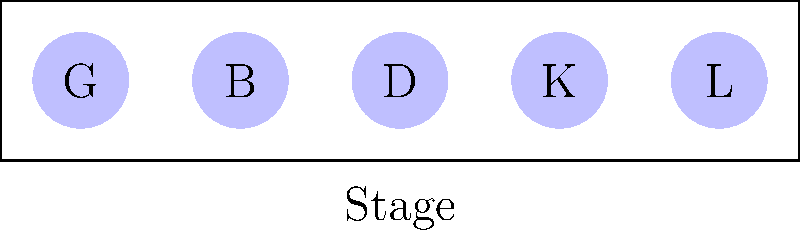At a Travis Tritt concert, his band members are arranged on stage in a line. If there are 5 band members (guitarist G, bassist B, drummer D, keyboardist K, and lead guitarist L), how many unique arrangements are possible if the drummer must always be in the middle position? Let's approach this step-by-step:

1) We know that the drummer (D) must always be in the middle position. This leaves 4 positions to be filled by the other 4 band members.

2) For the first position, we have 4 choices (G, B, K, or L).

3) After placing one musician, we have 3 choices for the second position.

4) For the fourth position (remember, the third/middle is fixed with D), we have 2 remaining choices.

5) The last position will be filled by the remaining musician.

6) This scenario follows the multiplication principle of counting.

7) Therefore, the total number of arrangements is:

   $$ 4 \times 3 \times 2 \times 1 = 24 $$

8) This is also equivalent to $4!$ (4 factorial), which represents the number of permutations of 4 distinct objects.

Thus, there are 24 possible unique arrangements of the band members with the drummer always in the middle position.
Answer: 24 